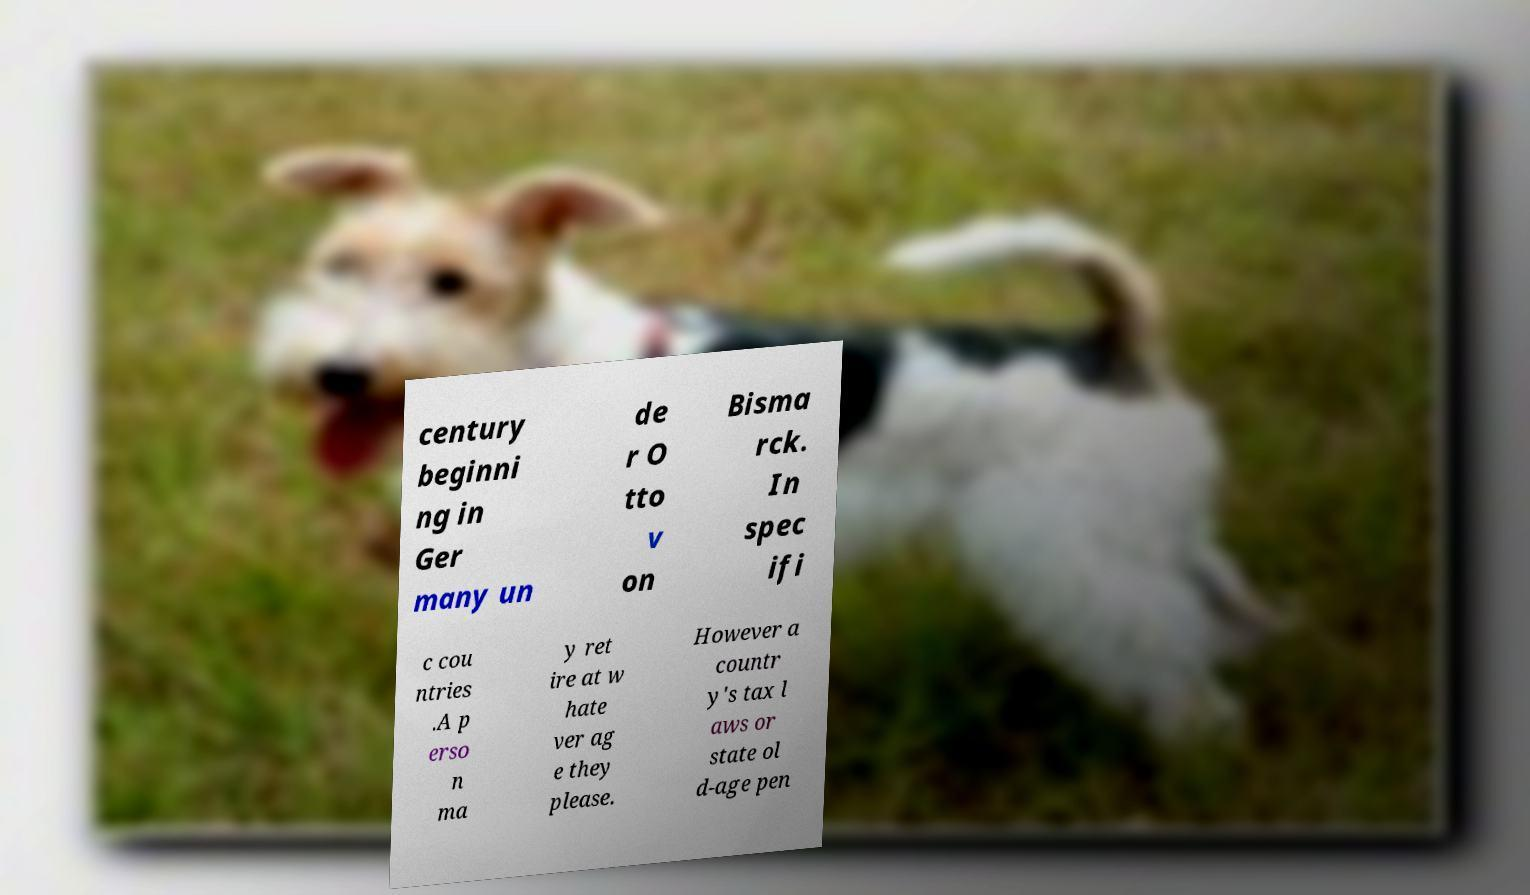I need the written content from this picture converted into text. Can you do that? century beginni ng in Ger many un de r O tto v on Bisma rck. In spec ifi c cou ntries .A p erso n ma y ret ire at w hate ver ag e they please. However a countr y's tax l aws or state ol d-age pen 